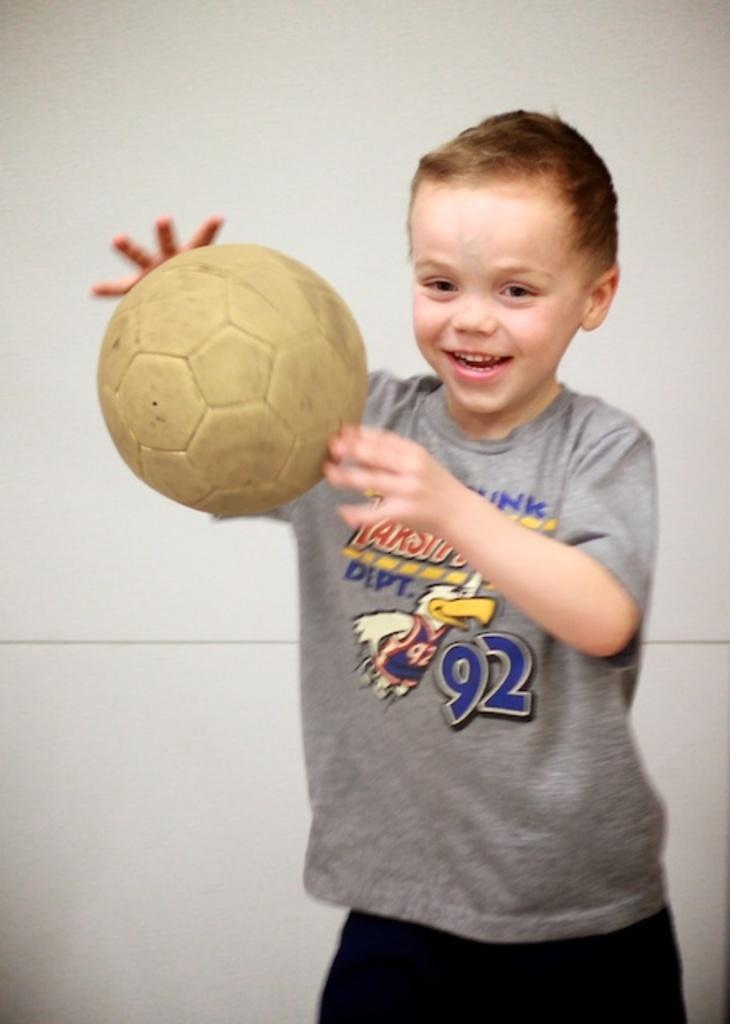Who is the main subject in the image? There is a boy in the image. What is the boy wearing? The boy is wearing a grey t-shirt and black pants. What is the boy holding in his hand? The boy is holding a ball in his hand. What is the boy's facial expression? The boy is smiling. What type of produce is the boy holding in the image? The boy is not holding any produce in the image; he is holding a ball. 